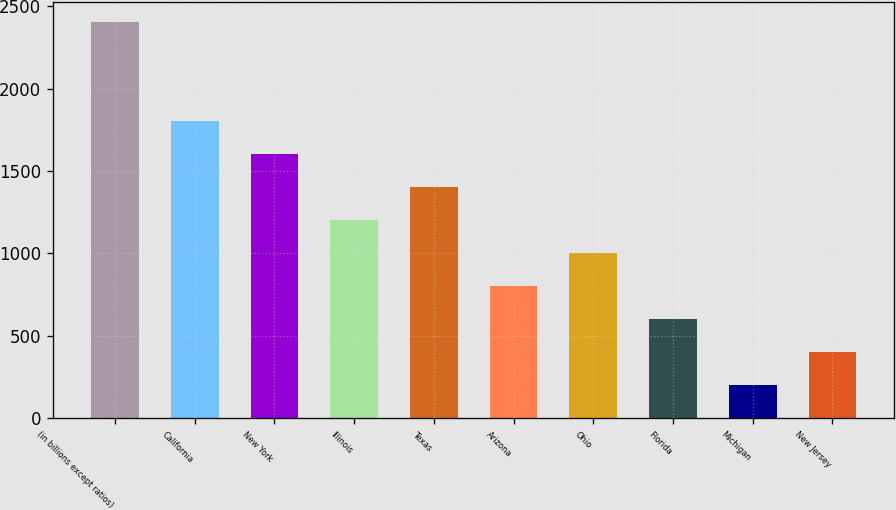<chart> <loc_0><loc_0><loc_500><loc_500><bar_chart><fcel>(in billions except ratios)<fcel>California<fcel>New York<fcel>Illinois<fcel>Texas<fcel>Arizona<fcel>Ohio<fcel>Florida<fcel>Michigan<fcel>New Jersey<nl><fcel>2406.6<fcel>1805.7<fcel>1605.4<fcel>1204.8<fcel>1405.1<fcel>804.2<fcel>1004.5<fcel>603.9<fcel>203.3<fcel>403.6<nl></chart> 